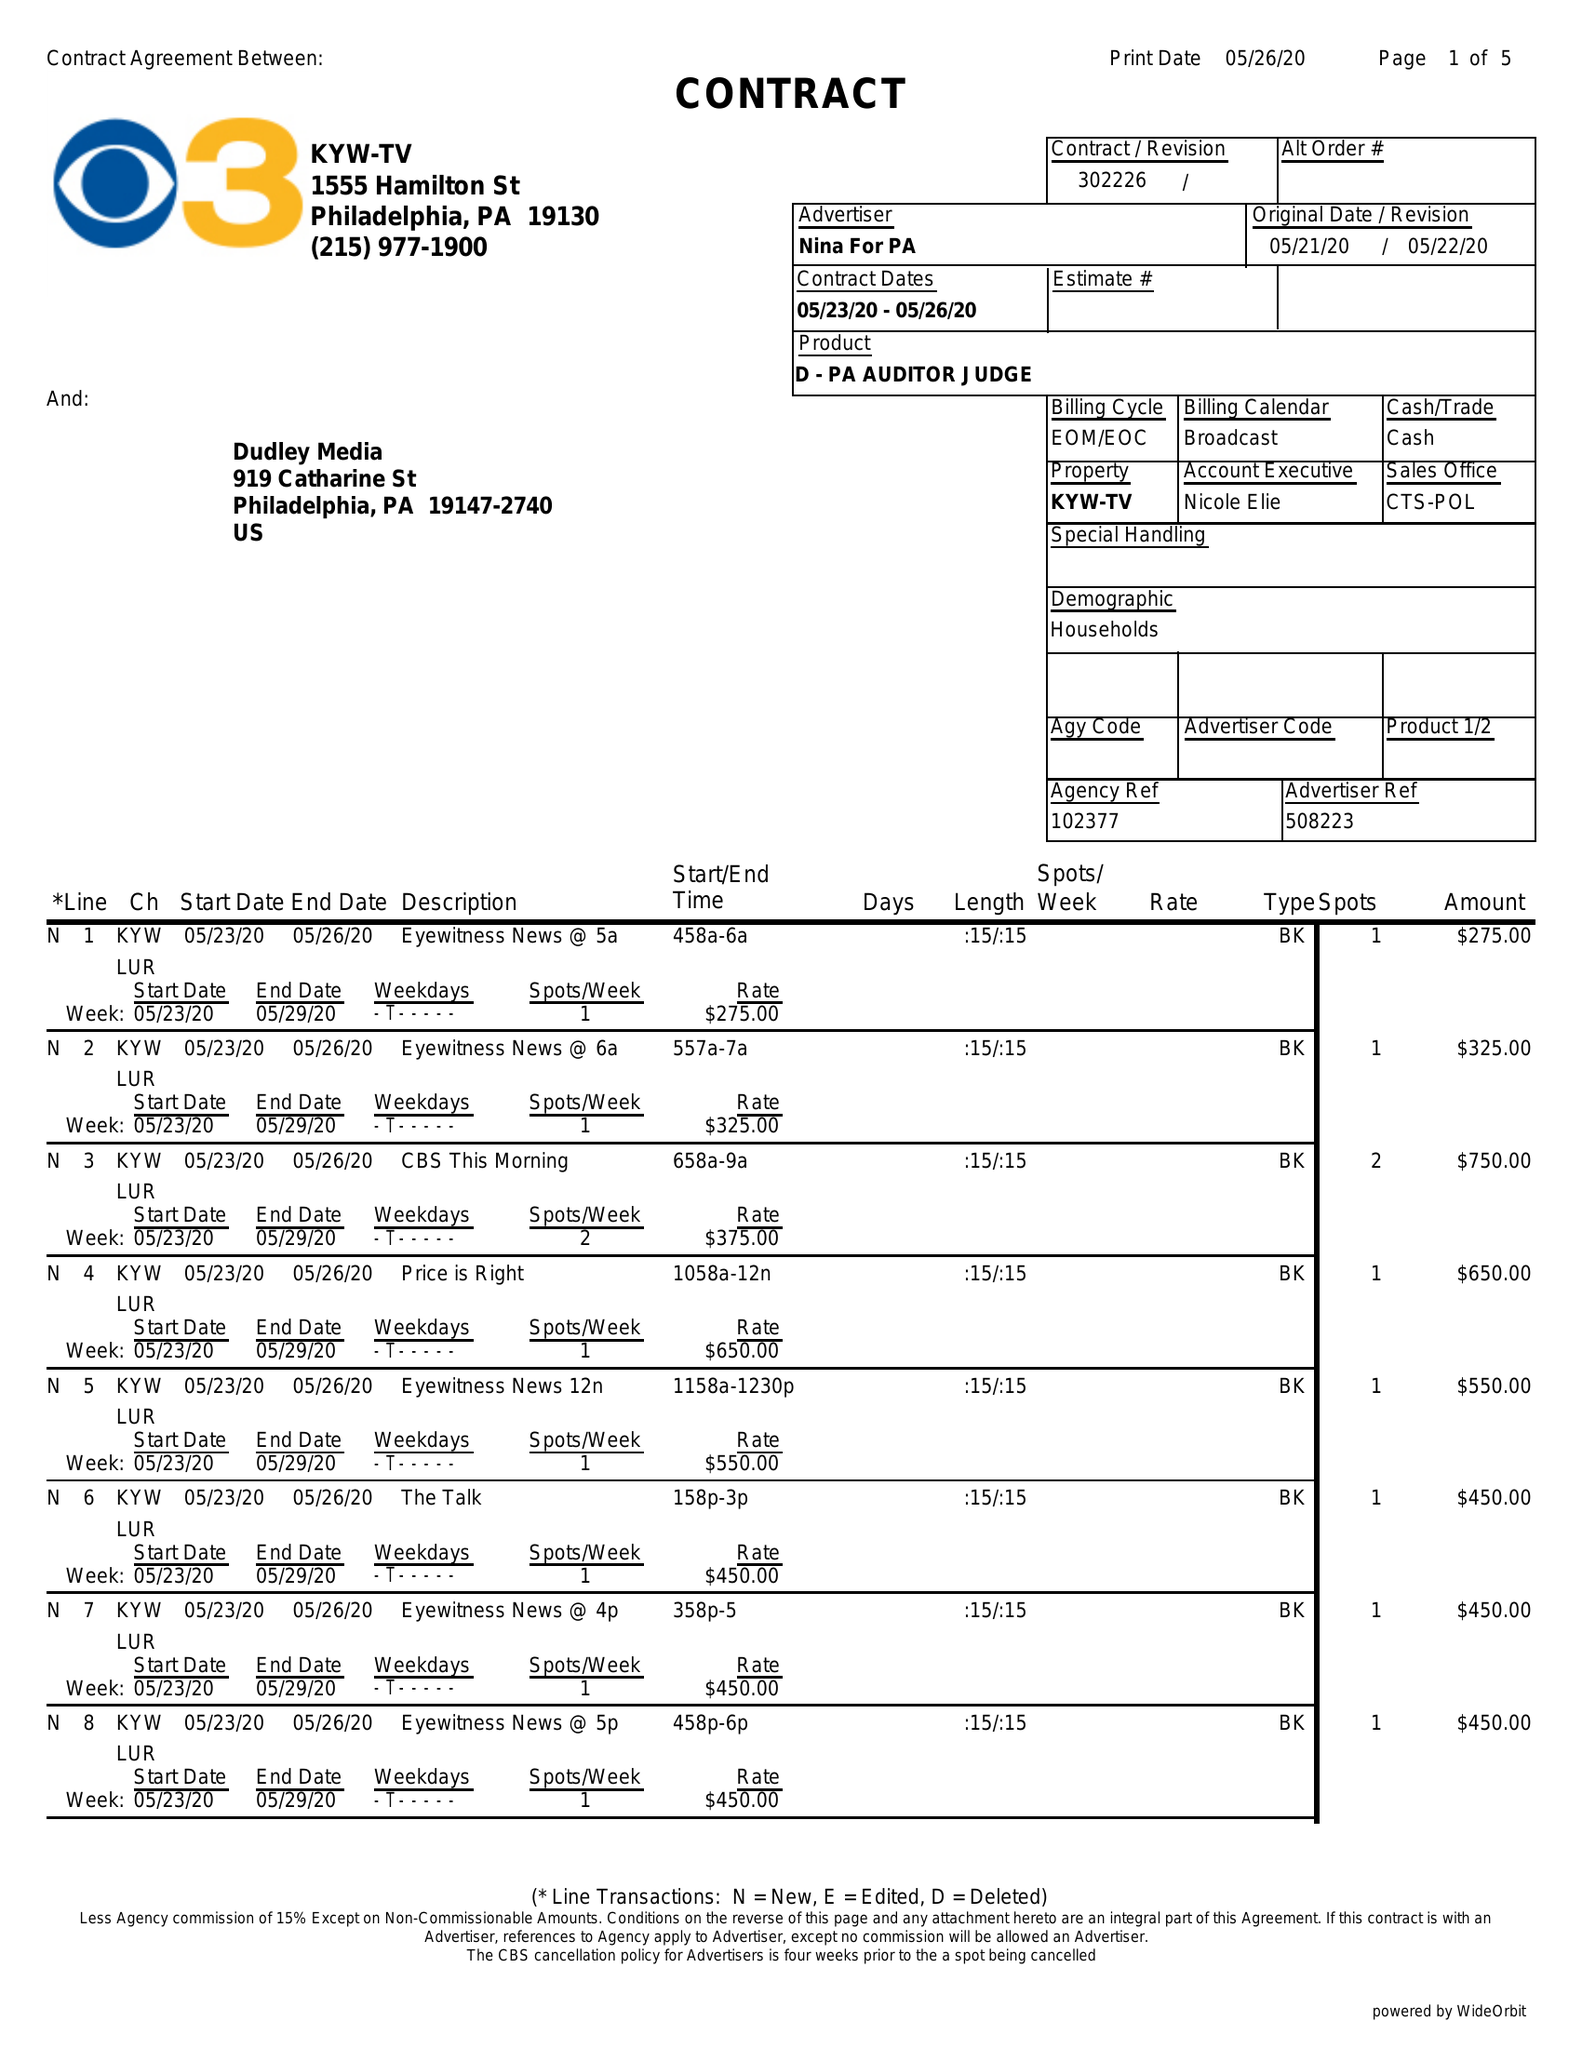What is the value for the contract_num?
Answer the question using a single word or phrase. 302226 